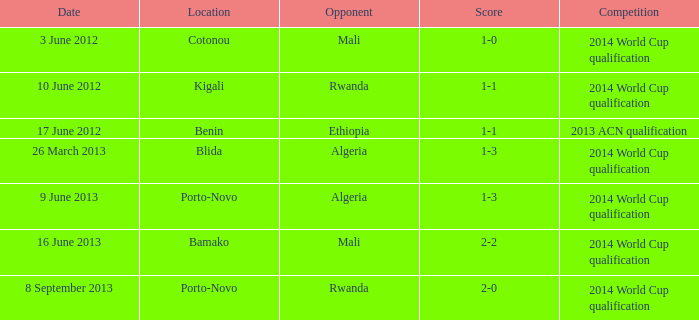What is the score from the game where Algeria is the opponent at Porto-Novo? 1-3. 